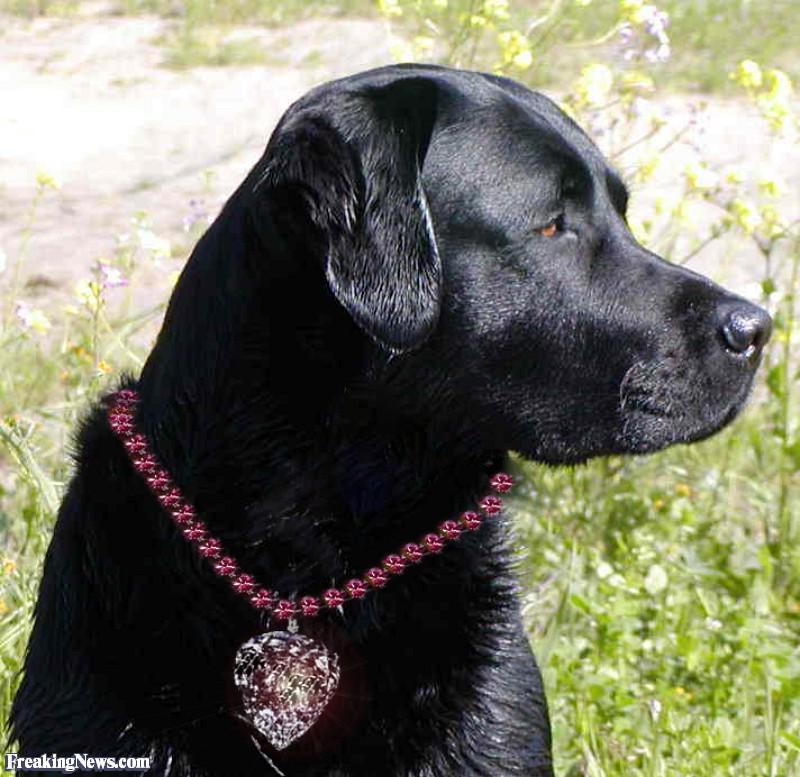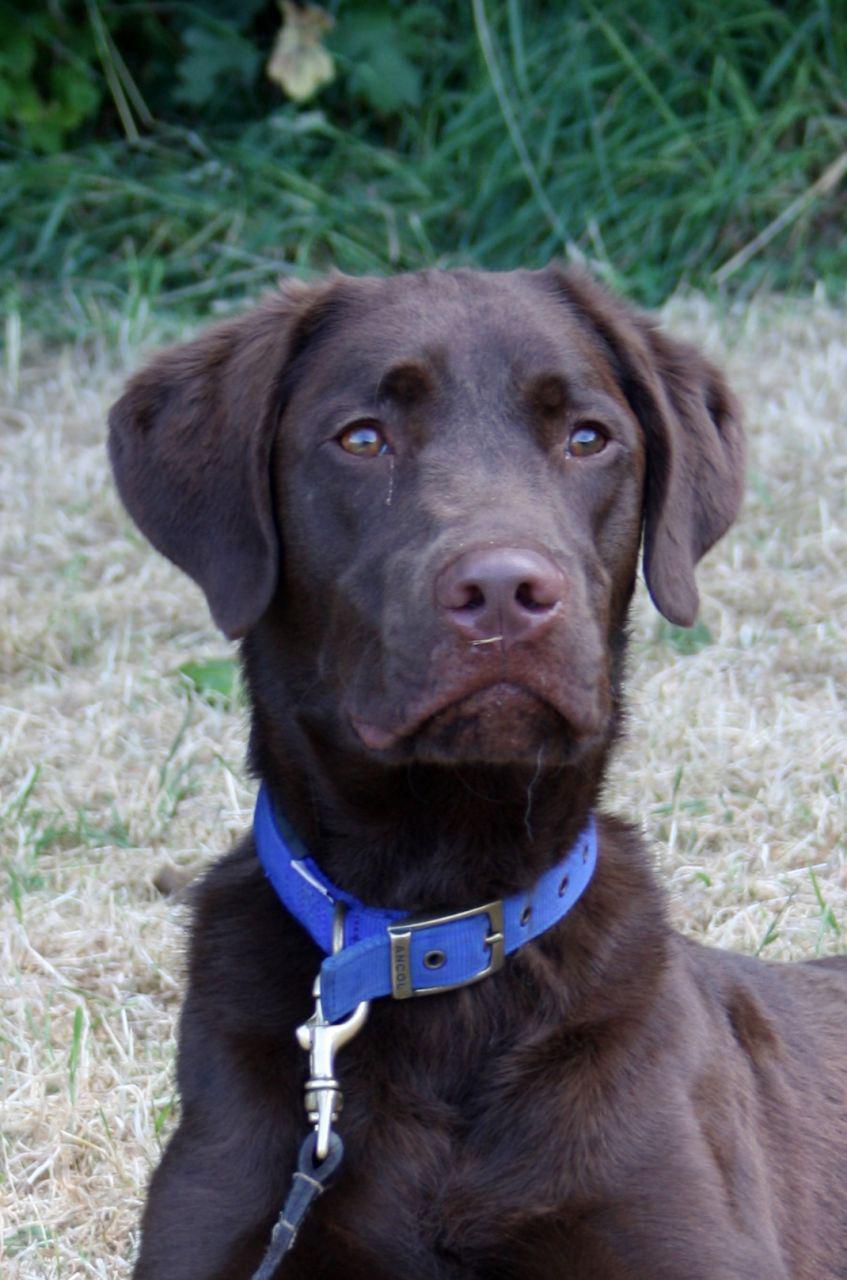The first image is the image on the left, the second image is the image on the right. For the images displayed, is the sentence "There's one black lab and one chocolate lab." factually correct? Answer yes or no. Yes. 